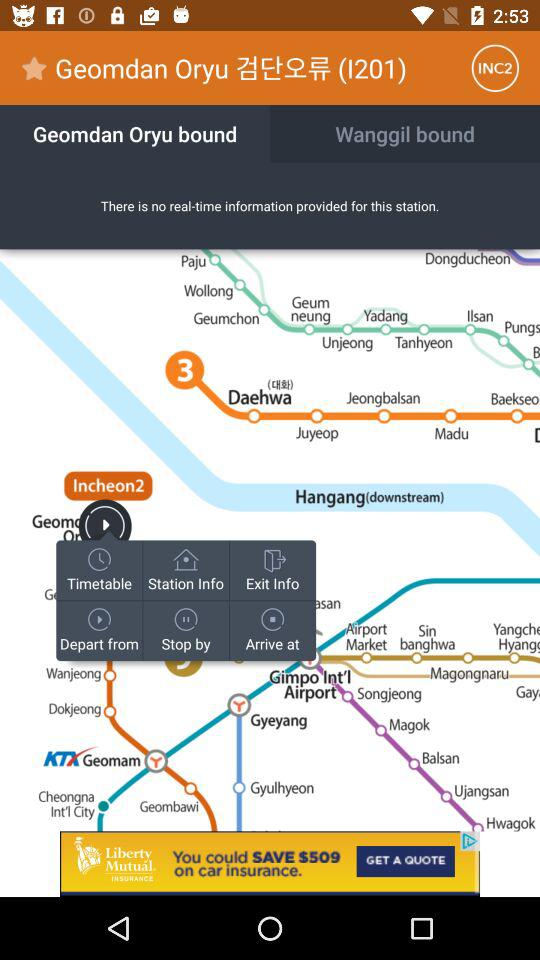When was the last version updated? The last version was updated on "2016.12.10". 